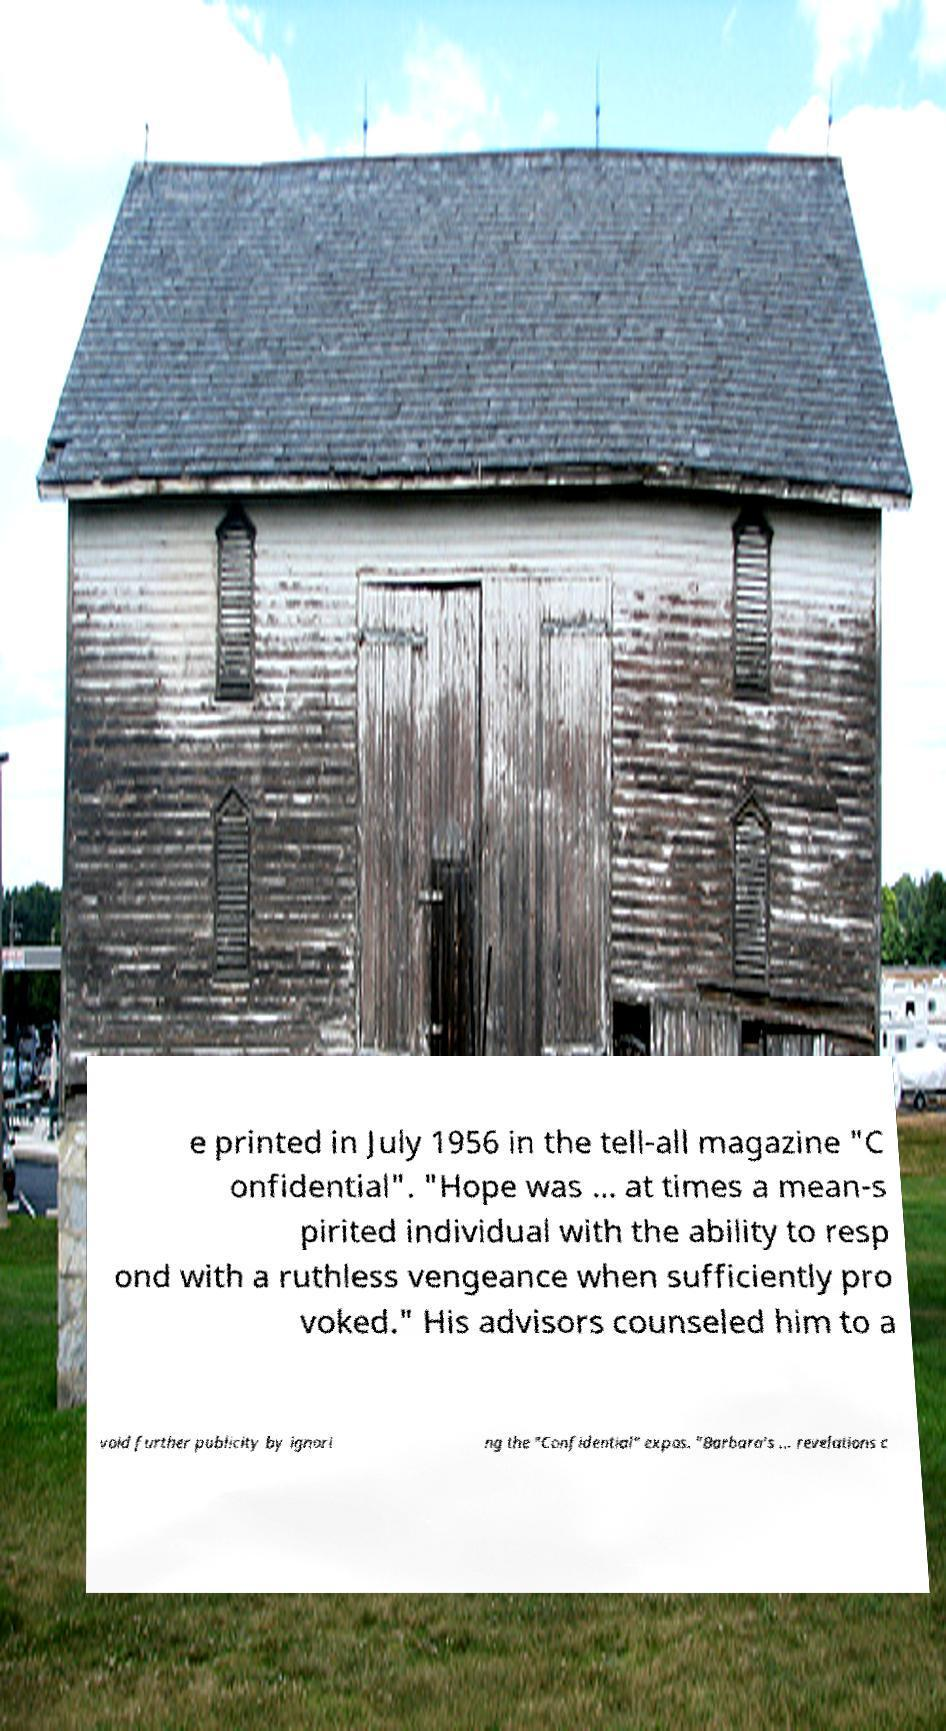Could you assist in decoding the text presented in this image and type it out clearly? e printed in July 1956 in the tell-all magazine "C onfidential". "Hope was ... at times a mean-s pirited individual with the ability to resp ond with a ruthless vengeance when sufficiently pro voked." His advisors counseled him to a void further publicity by ignori ng the "Confidential" expos. "Barbara's ... revelations c 